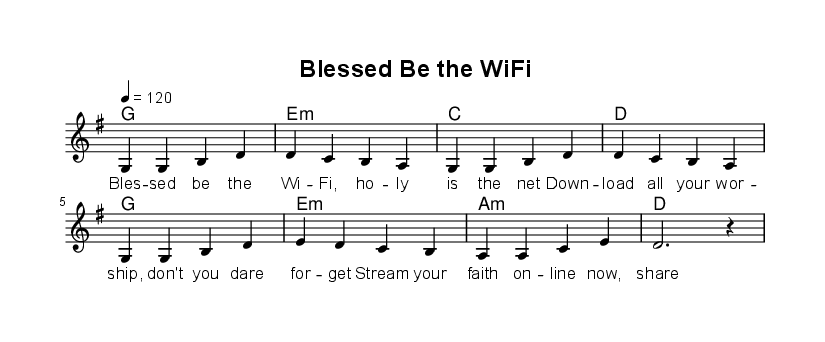What is the key signature of this music? The key signature is G major, which has one sharp (F#). This can be determined by looking at the key signature indicated before the staff in the sheet music.
Answer: G major What is the time signature of the piece? The time signature is 4/4, indicated at the beginning of the music. This means there are four beats in each measure, and the quarter note gets one beat.
Answer: 4/4 What is the tempo marking for this piece? The tempo marking is 4 = 120, which means the quarter note is to be played at 120 beats per minute. This is shown at the beginning of the score as a tempo indication.
Answer: 120 How many measures are present in the melody? There are eight measures in the melody, as counted by the number of vertical lines separating the groups of notes in the score.
Answer: 8 What are the first two chords in the harmony? The first two chords are G and E minor, which can be seen in the chord names written above the corresponding measures of the melody.
Answer: G, E minor What is the lyrical content's theme in the first line of the verse? The theme centers around technology and faith, specifically referencing Wi-Fi as a metaphor for spiritual connection. The lyrics reflect a modern take on worship.
Answer: Technology and faith Which note is held as a dotted half note in the melody? The note held as a dotted half note is D, indicated by its notation which shows that it is sustained for three beats in total.
Answer: D 